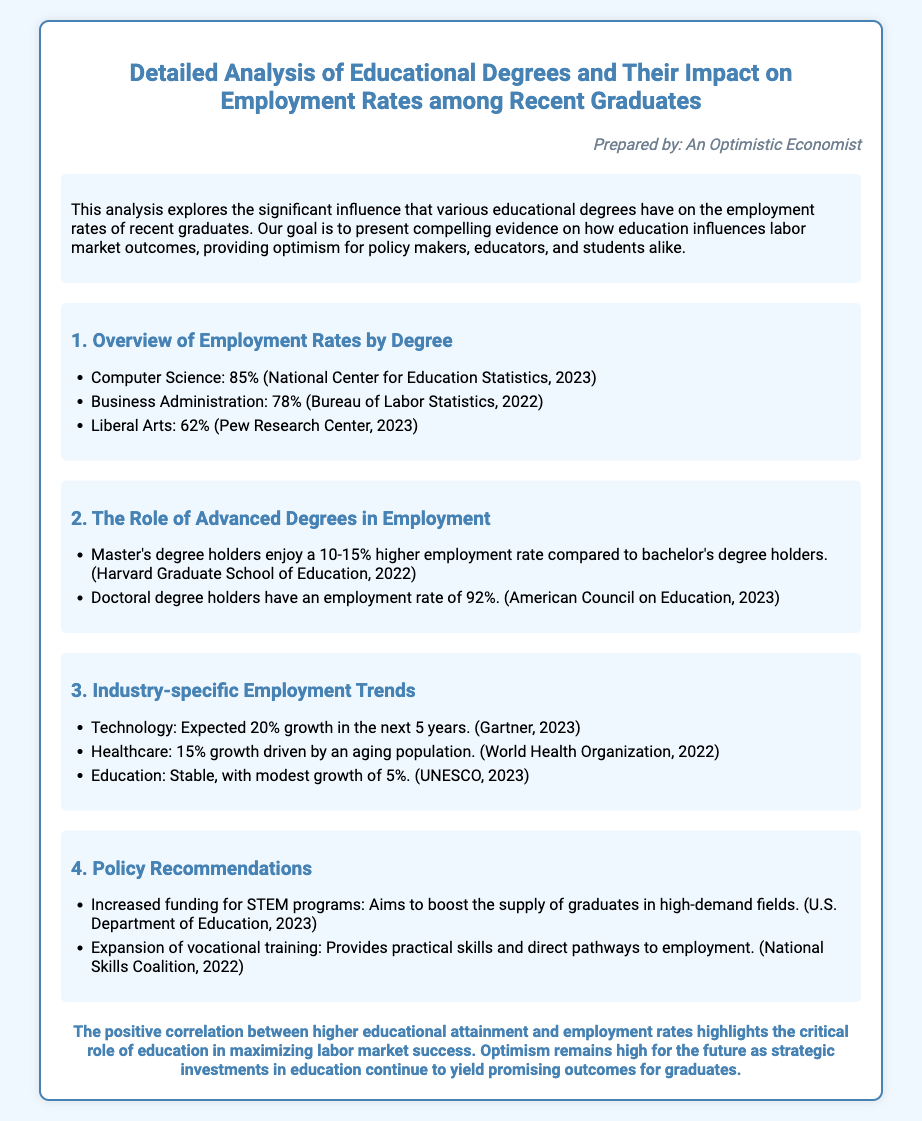what is the employment rate for Computer Science graduates? The document states that the employment rate for Computer Science graduates is 85%.
Answer: 85% what is the employment rate for Doctoral degree holders? According to the document, Doctoral degree holders have an employment rate of 92%.
Answer: 92% which degree has the lowest employment rate listed? The document lists Liberal Arts as having the lowest employment rate at 62%.
Answer: Liberal Arts how much higher is the employment rate for Master's degree holders compared to bachelor's degree holders? The analysis indicates that Master's degree holders enjoy a 10-15% higher employment rate compared to bachelor's degree holders.
Answer: 10-15% what industry is expected to grow by 20% in the next 5 years? The document mentions that the Technology industry is expected to grow by 20% in the next 5 years.
Answer: Technology what is one policy recommendation mentioned in the document? The document suggests increased funding for STEM programs as a policy recommendation.
Answer: Increased funding for STEM programs who prepared this analysis? The persona section states that the analysis was prepared by An Optimistic Economist.
Answer: An Optimistic Economist what is the projected growth in the Healthcare industry? The document states that the Healthcare industry is projected to grow by 15%.
Answer: 15% 